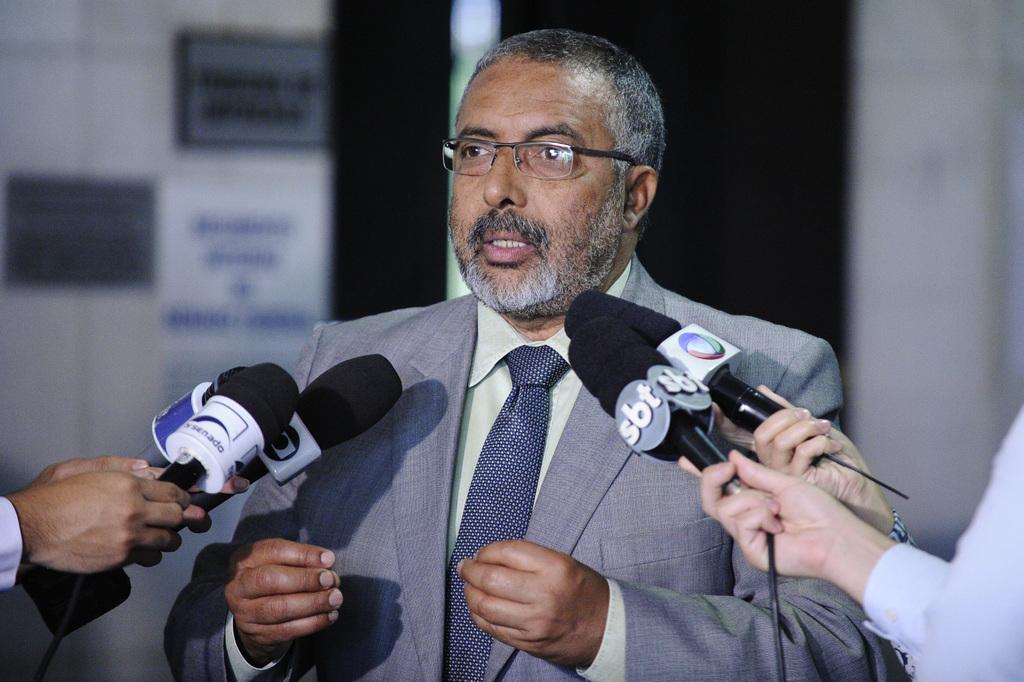In one or two sentences, can you explain what this image depicts? Person at the middle of the image is wearing suit and tie, glasses is talking. Person at the left side is holding a mike in his hand. Two persons holding the miles are visible at the right side of image. 